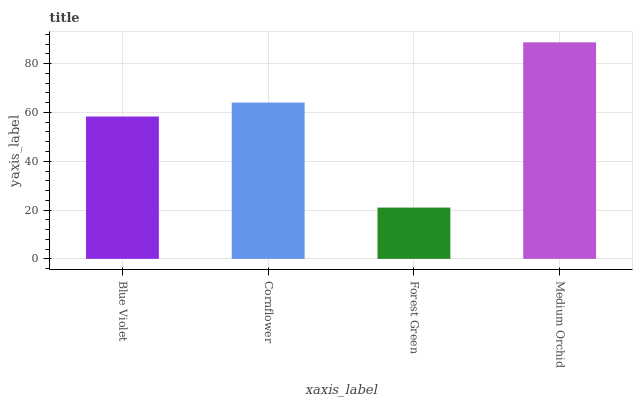Is Forest Green the minimum?
Answer yes or no. Yes. Is Medium Orchid the maximum?
Answer yes or no. Yes. Is Cornflower the minimum?
Answer yes or no. No. Is Cornflower the maximum?
Answer yes or no. No. Is Cornflower greater than Blue Violet?
Answer yes or no. Yes. Is Blue Violet less than Cornflower?
Answer yes or no. Yes. Is Blue Violet greater than Cornflower?
Answer yes or no. No. Is Cornflower less than Blue Violet?
Answer yes or no. No. Is Cornflower the high median?
Answer yes or no. Yes. Is Blue Violet the low median?
Answer yes or no. Yes. Is Forest Green the high median?
Answer yes or no. No. Is Forest Green the low median?
Answer yes or no. No. 